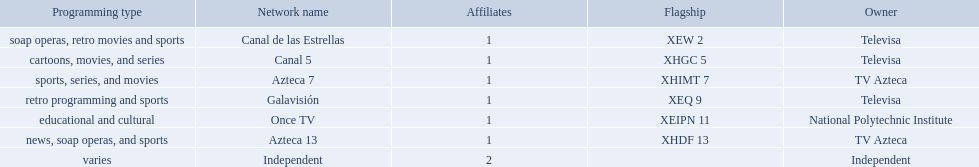What stations show sports? Soap operas, retro movies and sports, retro programming and sports, news, soap operas, and sports. What of these is not affiliated with televisa? Azteca 7. What are each of the networks? Canal de las Estrellas, Canal 5, Azteca 7, Galavisión, Once TV, Azteca 13, Independent. Who owns them? Televisa, Televisa, TV Azteca, Televisa, National Polytechnic Institute, TV Azteca, Independent. Which networks aren't owned by televisa? Azteca 7, Once TV, Azteca 13, Independent. What type of programming do those networks offer? Sports, series, and movies, educational and cultural, news, soap operas, and sports, varies. And which network is the only one with sports? Azteca 7. 